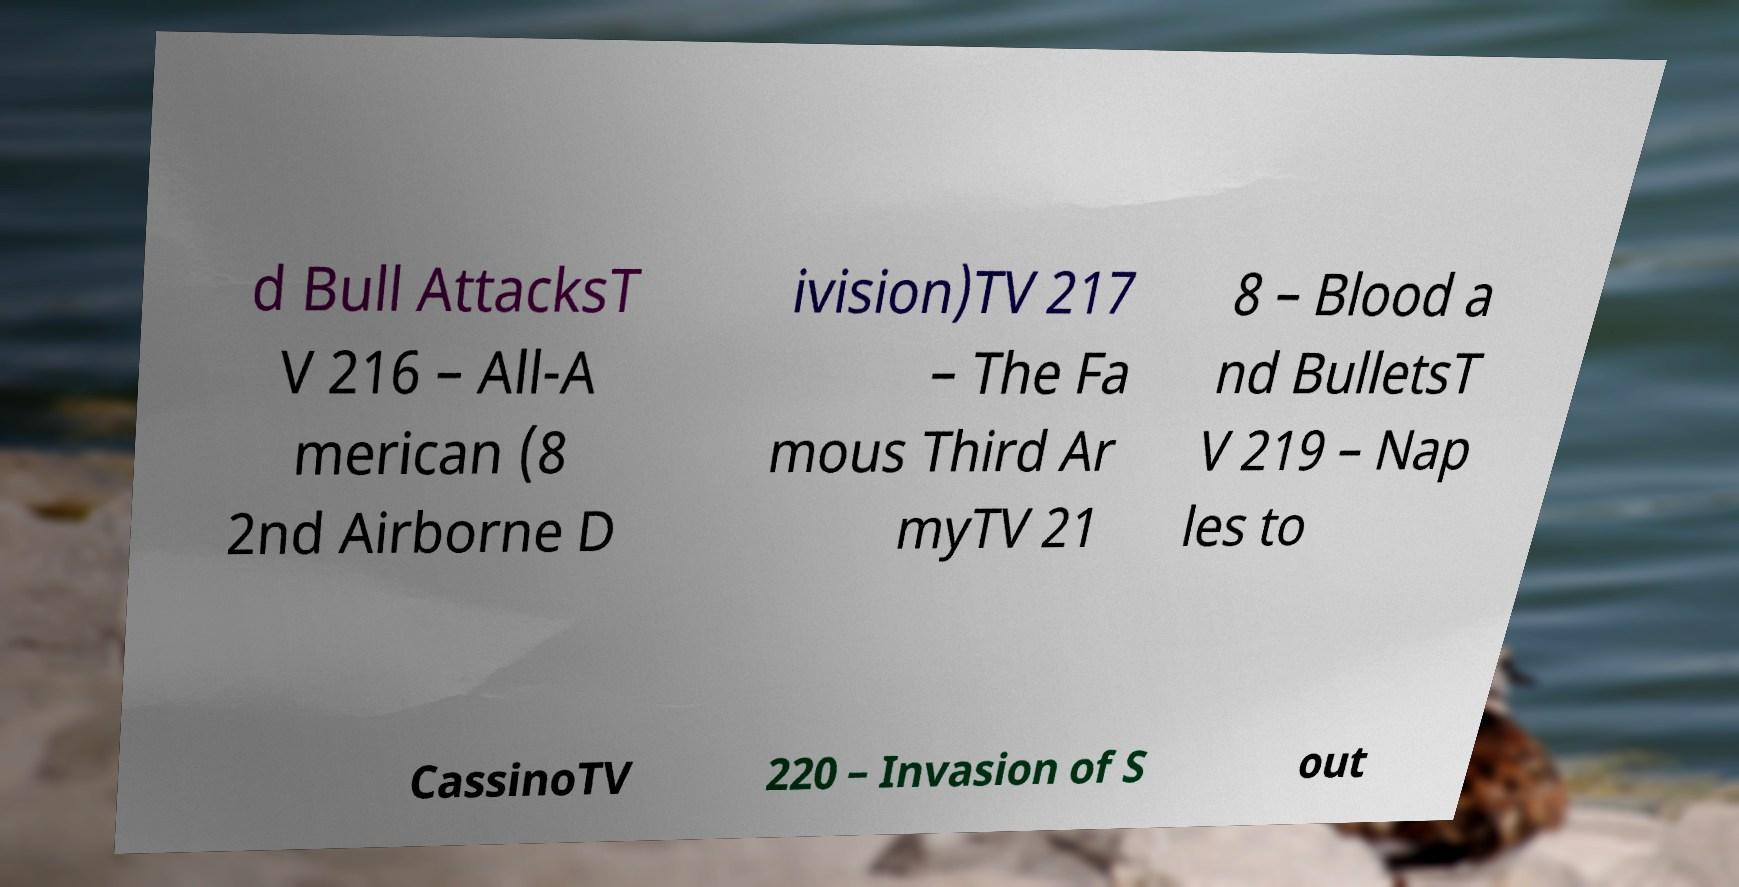I need the written content from this picture converted into text. Can you do that? d Bull AttacksT V 216 – All-A merican (8 2nd Airborne D ivision)TV 217 – The Fa mous Third Ar myTV 21 8 – Blood a nd BulletsT V 219 – Nap les to CassinoTV 220 – Invasion of S out 